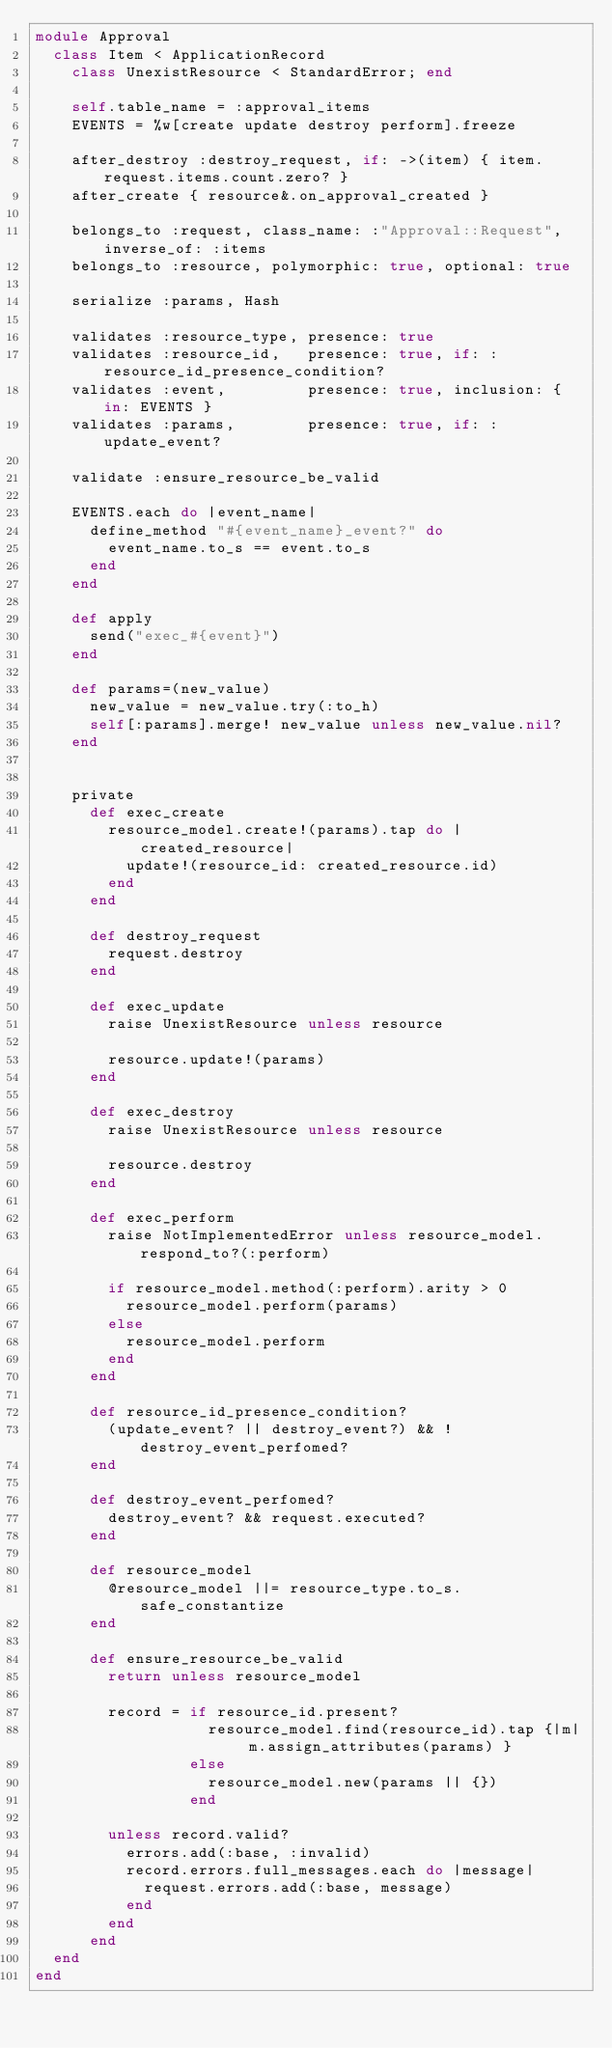<code> <loc_0><loc_0><loc_500><loc_500><_Ruby_>module Approval
  class Item < ApplicationRecord
    class UnexistResource < StandardError; end

    self.table_name = :approval_items
    EVENTS = %w[create update destroy perform].freeze

    after_destroy :destroy_request, if: ->(item) { item.request.items.count.zero? }
    after_create { resource&.on_approval_created }

    belongs_to :request, class_name: :"Approval::Request", inverse_of: :items
    belongs_to :resource, polymorphic: true, optional: true

    serialize :params, Hash

    validates :resource_type, presence: true
    validates :resource_id,   presence: true, if: :resource_id_presence_condition?
    validates :event,         presence: true, inclusion: { in: EVENTS }
    validates :params,        presence: true, if: :update_event?

    validate :ensure_resource_be_valid

    EVENTS.each do |event_name|
      define_method "#{event_name}_event?" do
        event_name.to_s == event.to_s
      end
    end

    def apply
      send("exec_#{event}")
    end

    def params=(new_value)
      new_value = new_value.try(:to_h)
      self[:params].merge! new_value unless new_value.nil?
    end


    private
      def exec_create
        resource_model.create!(params).tap do |created_resource|
          update!(resource_id: created_resource.id)
        end
      end

      def destroy_request
        request.destroy
      end

      def exec_update
        raise UnexistResource unless resource

        resource.update!(params)
      end

      def exec_destroy
        raise UnexistResource unless resource

        resource.destroy
      end

      def exec_perform
        raise NotImplementedError unless resource_model.respond_to?(:perform)

        if resource_model.method(:perform).arity > 0
          resource_model.perform(params)
        else
          resource_model.perform
        end
      end

      def resource_id_presence_condition?
        (update_event? || destroy_event?) && !destroy_event_perfomed?
      end

      def destroy_event_perfomed?
        destroy_event? && request.executed?
      end

      def resource_model
        @resource_model ||= resource_type.to_s.safe_constantize
      end

      def ensure_resource_be_valid
        return unless resource_model

        record = if resource_id.present?
                   resource_model.find(resource_id).tap {|m| m.assign_attributes(params) }
                 else
                   resource_model.new(params || {})
                 end

        unless record.valid?
          errors.add(:base, :invalid)
          record.errors.full_messages.each do |message|
            request.errors.add(:base, message)
          end
        end
      end
  end
end
</code> 